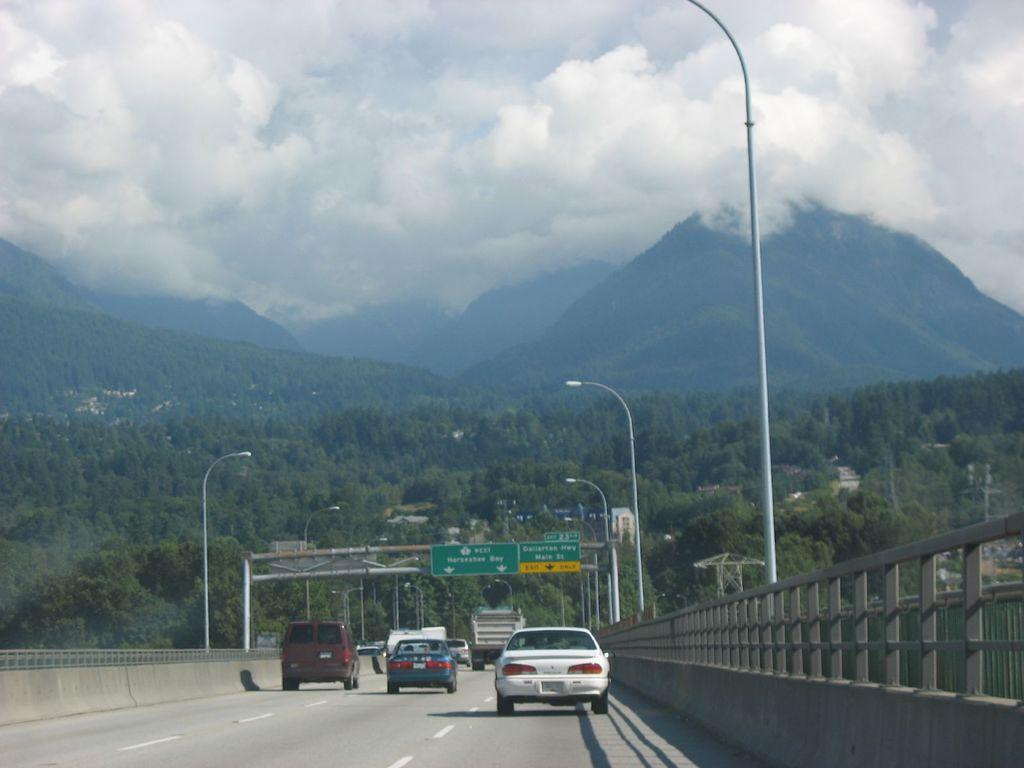Please provide a concise description of this image. In this image there is a road and we can see vehicles on the road. There are sign boards and we can see poles. In the background there are trees, hills and sky. 